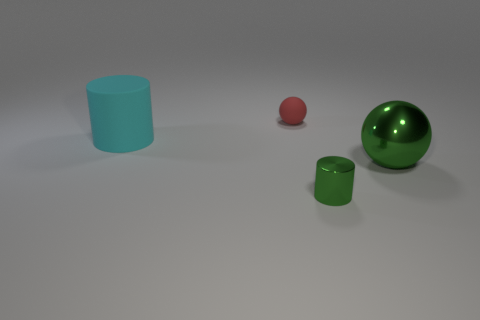Subtract all cyan cylinders. How many cylinders are left? 1 Add 1 tiny purple things. How many objects exist? 5 Subtract 0 yellow spheres. How many objects are left? 4 Subtract 1 balls. How many balls are left? 1 Subtract all cyan cylinders. Subtract all cyan balls. How many cylinders are left? 1 Subtract all brown blocks. How many cyan cylinders are left? 1 Subtract all red matte balls. Subtract all red balls. How many objects are left? 2 Add 4 tiny balls. How many tiny balls are left? 5 Add 1 shiny cylinders. How many shiny cylinders exist? 2 